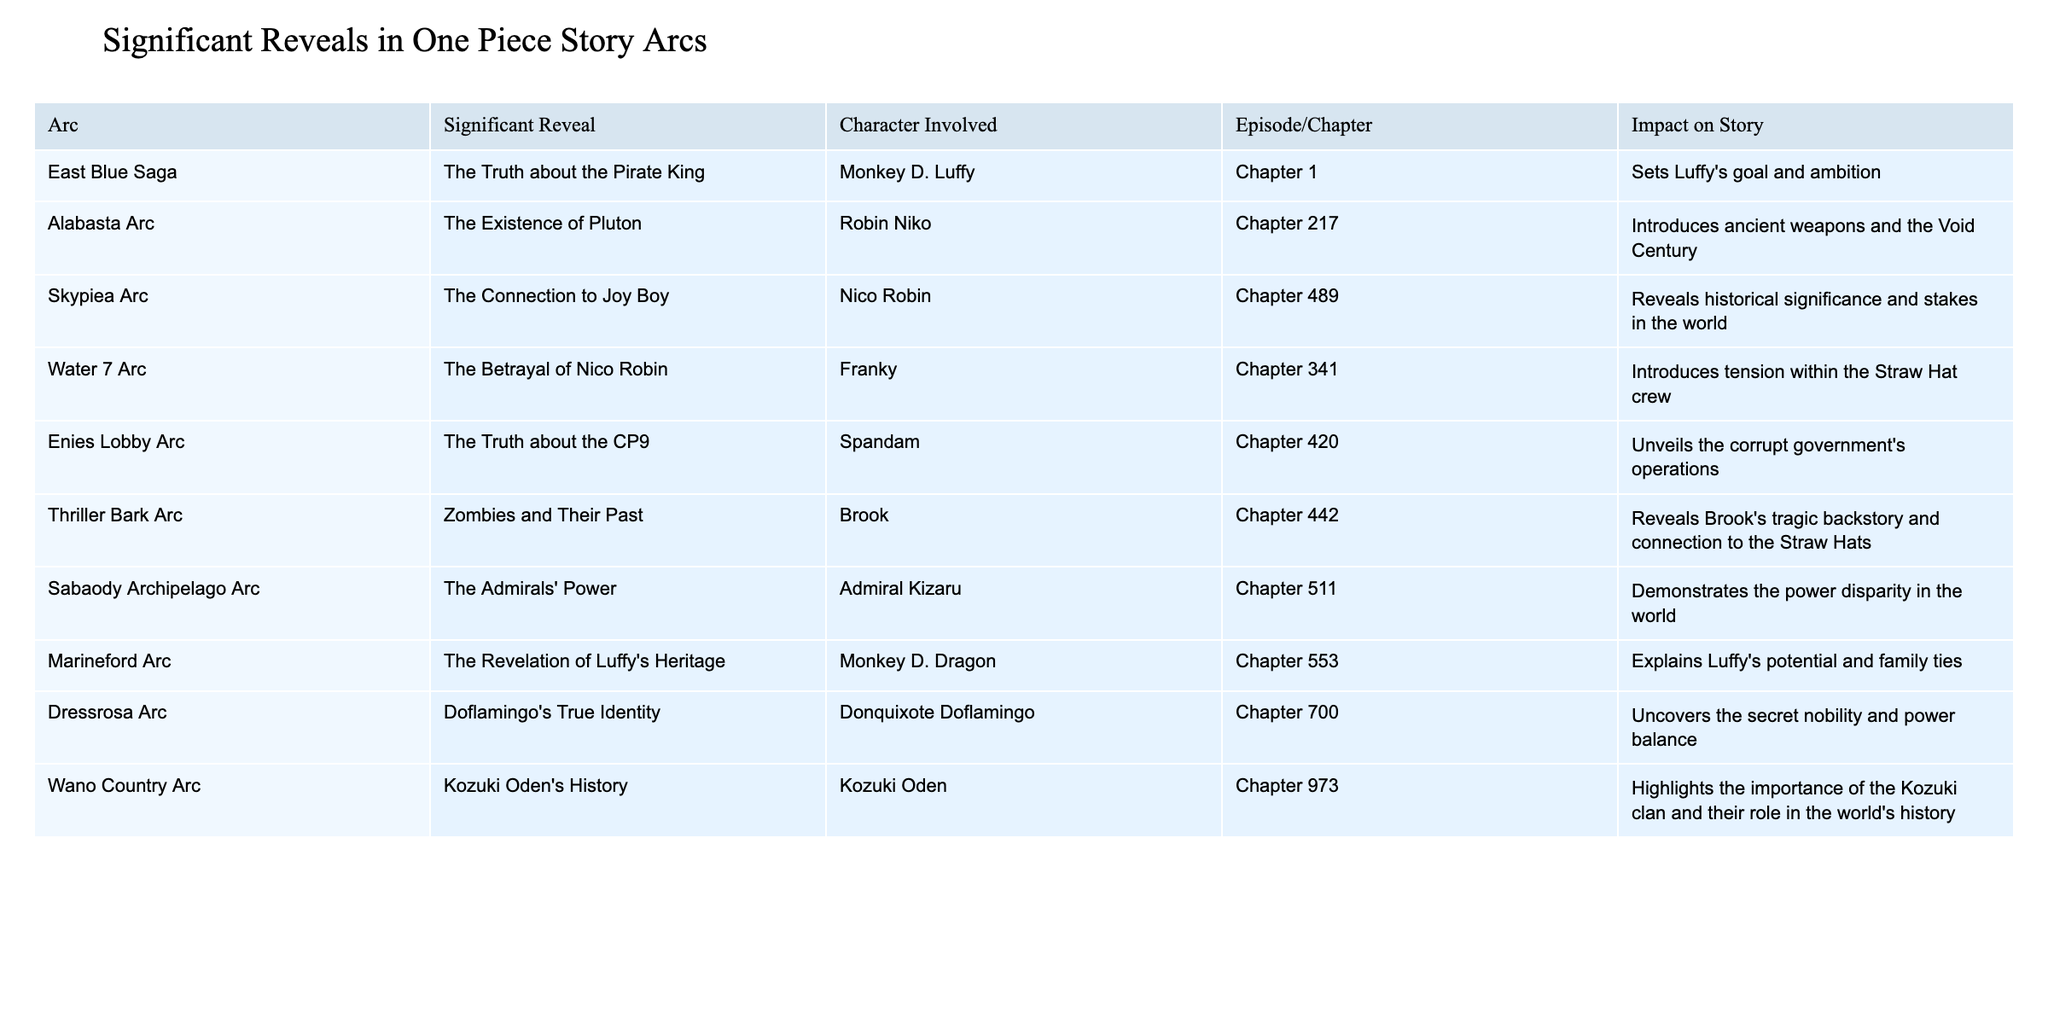What significant reveal is associated with Chapter 217? Chapter 217 is noted in the table as the chapter that introduces the existence of Pluton, involving the character Robin Niko.
Answer: The existence of Pluton Which character is involved in the reveal about Joy Boy's connection in the Skypiea Arc? The table indicates that Nico Robin is the character involved in the reveal regarding the connection to Joy Boy in the Skypiea Arc.
Answer: Nico Robin How many chapters focus on significant reveals related to Monkey D. Luffy? In the table, Luffy is mentioned twice: once in Chapter 1 (The Truth about the Pirate King) and once in Chapter 553 (The Revelation of Luffy's Heritage), which totals two chapters.
Answer: 2 chapters What impact does the reveal about Doflamingo's true identity have on the story? According to the table, this reveal uncovers the secret nobility and power balance, which is a crucial element in the storyline.
Answer: Uncovers secret nobility and power balance Is the introduction of ancient weapons discussed in the Water 7 Arc? The data reveals that ancient weapons are discussed in the Alabasta Arc, not in the Water 7 Arc. Therefore, the statement is false.
Answer: False Which reveal has the highest impact on the story according to the table? Examining the impact descriptions, the reveals about the CP9 in the Enies Lobby Arc and the Betrayal of Nico Robin in the Water 7 Arc introduce significant tensions and stakes, but the revelation of Luffy's heritage significantly explains his potential and family ties, making it stand out in terms of impact.
Answer: The Revelation of Luffy's Heritage What is the connection between Kozuki Oden and Wano Country Arc's significance? The table states that Kozuki Oden's history highlights the importance of the Kozuki clan, signifying its vital role in world history, indicating a deeper connection to the overarching narrative in One Piece.
Answer: Importance of the Kozuki clan In which arc does the reveal about the Admirals' power occur, and what does it demonstrate? The table shows that this reveal occurs in the Sabaody Archipelago Arc and demonstrates the power disparity in the world of One Piece.
Answer: Sabaody Archipelago Arc; demonstrates power disparity What are the total numbers of reveals involving Nico Robin throughout the arcs listed? The table indicates that Nico Robin is involved in three major reveals: the Truth about Joy Boy in Skypiea, the Betrayal in Water 7 Arc, and the existence of Pluton in Alabasta, totaling three reveals.
Answer: 3 reveals What reveal occurs in the Thriller Bark Arc and what is its significance? The reveal in the Thriller Bark Arc discusses Zombies and their past, which reveals Brook's tragic backstory and connection to the Straw Hats, showing its significance in character development.
Answer: Brook's tragic backstory and connection to Straw Hats 